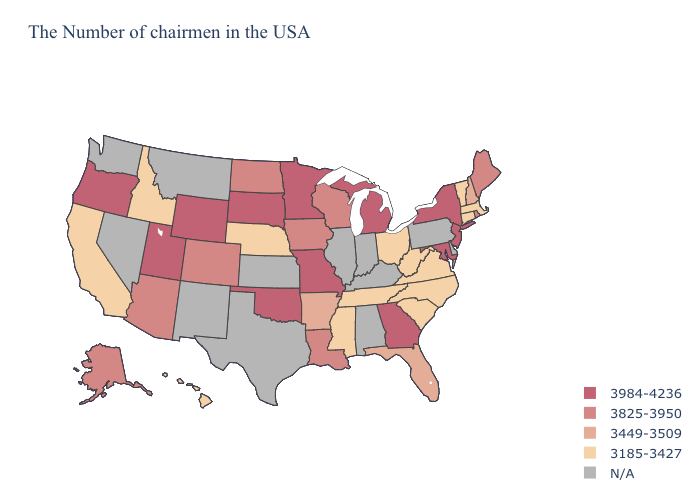Does the map have missing data?
Answer briefly. Yes. Among the states that border Mississippi , which have the lowest value?
Be succinct. Tennessee. Among the states that border Nebraska , which have the lowest value?
Write a very short answer. Iowa, Colorado. Does Oklahoma have the highest value in the South?
Keep it brief. Yes. Name the states that have a value in the range N/A?
Quick response, please. Delaware, Pennsylvania, Kentucky, Indiana, Alabama, Illinois, Kansas, Texas, New Mexico, Montana, Nevada, Washington. What is the value of North Carolina?
Keep it brief. 3185-3427. What is the value of Washington?
Concise answer only. N/A. What is the value of Kentucky?
Quick response, please. N/A. What is the value of Nevada?
Keep it brief. N/A. What is the value of California?
Quick response, please. 3185-3427. What is the value of Connecticut?
Quick response, please. 3185-3427. What is the value of Georgia?
Quick response, please. 3984-4236. What is the value of Pennsylvania?
Give a very brief answer. N/A. What is the highest value in states that border Kentucky?
Quick response, please. 3984-4236. 